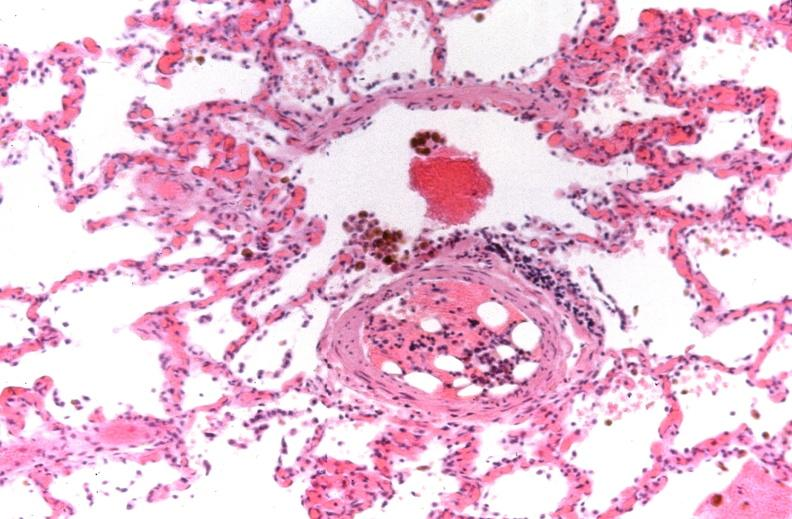where is this?
Answer the question using a single word or phrase. Lung 